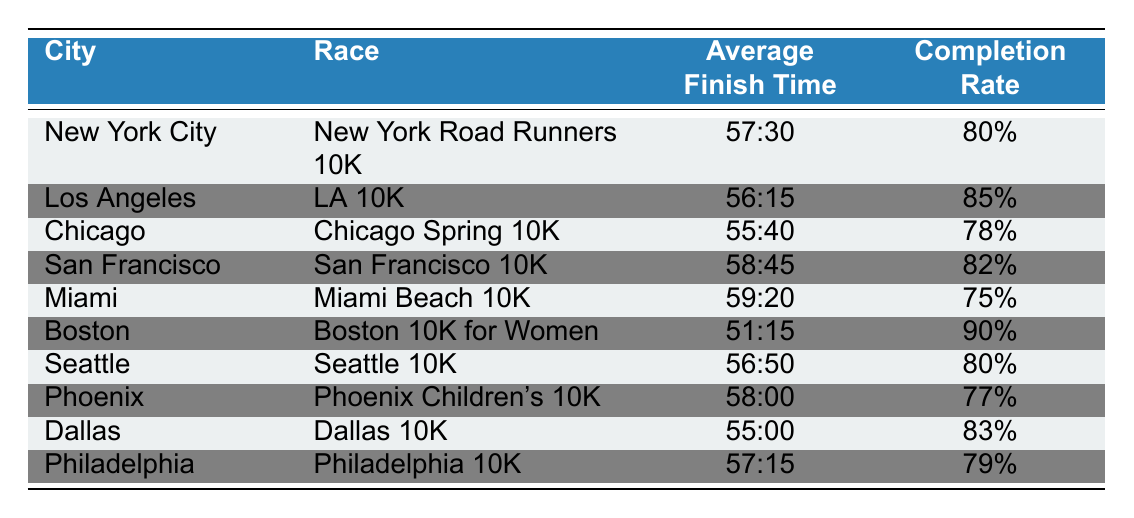What is the average finish time for the Boston race? The table lists the Boston race as "Boston 10K for Women," and its average finish time is shown as "51:15."
Answer: 51:15 Which city has the highest completion rate? The completion rates in the table show that Boston has the highest rate at 90%.
Answer: Boston What is the average finish time for races in Chicago and Dallas combined? The average finish time for Chicago is 55:40 and for Dallas is 55:00. Converting these to total seconds gives (55*60 + 40) = 3340 seconds for Chicago and (55*60 + 0) = 3300 seconds for Dallas. The sum is 6640 seconds, and to find the average, divide by 2, resulting in 6640/2 = 3320 seconds, which is 55:20.
Answer: 55:20 Is the completion rate for the Miami race higher than that of Los Angeles? The completion rate for Miami is 75% and for Los Angeles is 85%. Since 75% is less than 85%, the answer is no.
Answer: No What is the difference in average finish times between the San Francisco 10K and the Dallas 10K? San Francisco's average finish time is 58:45 and Dallas's is 55:00. Converting these to seconds gives 3525 seconds for San Francisco and 3300 seconds for Dallas. The difference is 3525 - 3300 = 225 seconds, which converts back to 3 minutes and 45 seconds, or 3:45.
Answer: 3:45 Which city’s race had a completion rate lower than 80%? By reviewing the completion rates in the table, Miami (75%) and Chicago (78%) both had completion rates lower than 80%.
Answer: Miami and Chicago What is the average completion rate across all races listed? Summing the completion rates: 80% + 85% + 78% + 82% + 75% + 90% + 80% + 77% + 83% + 79% = 80.9%. Dividing this by 10 gives an average completion rate of 80.9%.
Answer: 80.9% Which city has the second highest average finish time for a 10K race? By comparing the average finish times, San Francisco (58:45) has the second highest finish time, following Miami (59:20).
Answer: San Francisco Is the average finish time for the LA 10K race better than the average for the Seattle race? The average finish time for LA is 56:15, while for Seattle it is 56:50. Since 56:15 is less than 56:50, the answer is yes.
Answer: Yes How does the average finish time for the Chicago race compare to the national average of the listed races? The overall average finish time of the listed races is 56:45 calculated from the individual times. Chicago's time of 55:40 is better than this average.
Answer: Better 